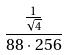Convert formula to latex. <formula><loc_0><loc_0><loc_500><loc_500>\frac { \frac { 1 } { \sqrt { 4 } } } { 8 8 \cdot 2 5 6 }</formula> 